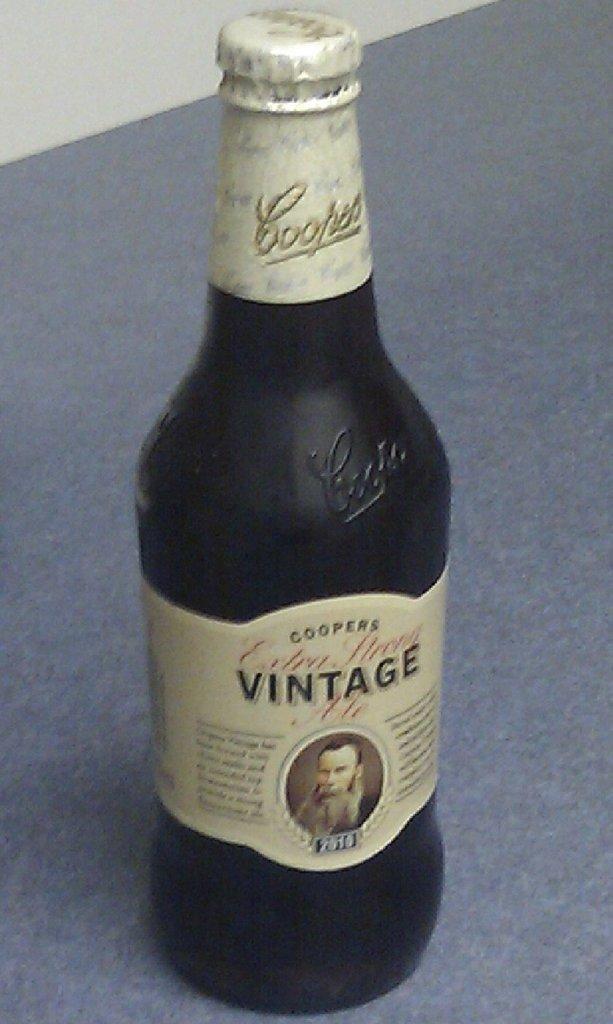Does this bottle say whether or not it's vintage?
Your answer should be very brief. Yes. 